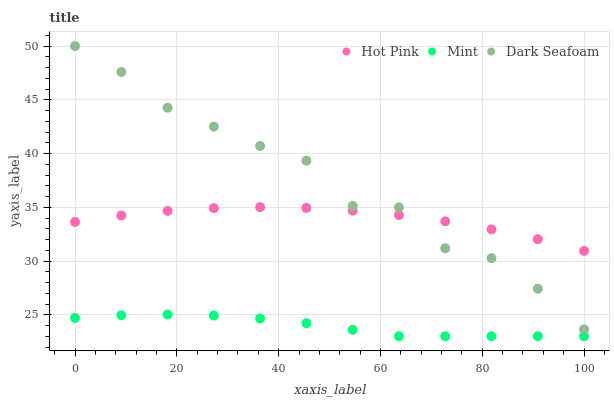Does Mint have the minimum area under the curve?
Answer yes or no. Yes. Does Dark Seafoam have the maximum area under the curve?
Answer yes or no. Yes. Does Hot Pink have the minimum area under the curve?
Answer yes or no. No. Does Hot Pink have the maximum area under the curve?
Answer yes or no. No. Is Mint the smoothest?
Answer yes or no. Yes. Is Dark Seafoam the roughest?
Answer yes or no. Yes. Is Hot Pink the smoothest?
Answer yes or no. No. Is Hot Pink the roughest?
Answer yes or no. No. Does Mint have the lowest value?
Answer yes or no. Yes. Does Hot Pink have the lowest value?
Answer yes or no. No. Does Dark Seafoam have the highest value?
Answer yes or no. Yes. Does Hot Pink have the highest value?
Answer yes or no. No. Is Mint less than Dark Seafoam?
Answer yes or no. Yes. Is Dark Seafoam greater than Mint?
Answer yes or no. Yes. Does Hot Pink intersect Dark Seafoam?
Answer yes or no. Yes. Is Hot Pink less than Dark Seafoam?
Answer yes or no. No. Is Hot Pink greater than Dark Seafoam?
Answer yes or no. No. Does Mint intersect Dark Seafoam?
Answer yes or no. No. 